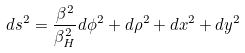Convert formula to latex. <formula><loc_0><loc_0><loc_500><loc_500>d s ^ { 2 } = { \frac { \beta ^ { 2 } } { \beta _ { H } ^ { 2 } } } d \phi ^ { 2 } + d \rho ^ { 2 } + d x ^ { 2 } + d y ^ { 2 }</formula> 